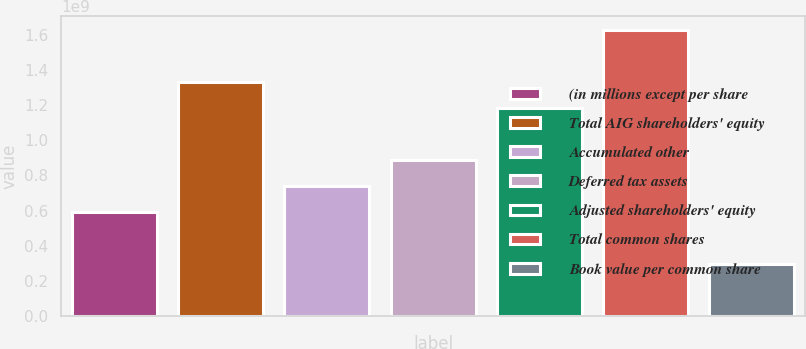<chart> <loc_0><loc_0><loc_500><loc_500><bar_chart><fcel>(in millions except per share<fcel>Total AIG shareholders' equity<fcel>Accumulated other<fcel>Deferred tax assets<fcel>Adjusted shareholders' equity<fcel>Total common shares<fcel>Book value per common share<nl><fcel>5.90529e+08<fcel>1.32869e+09<fcel>7.38161e+08<fcel>8.85793e+08<fcel>1.18106e+09<fcel>1.62395e+09<fcel>2.95264e+08<nl></chart> 